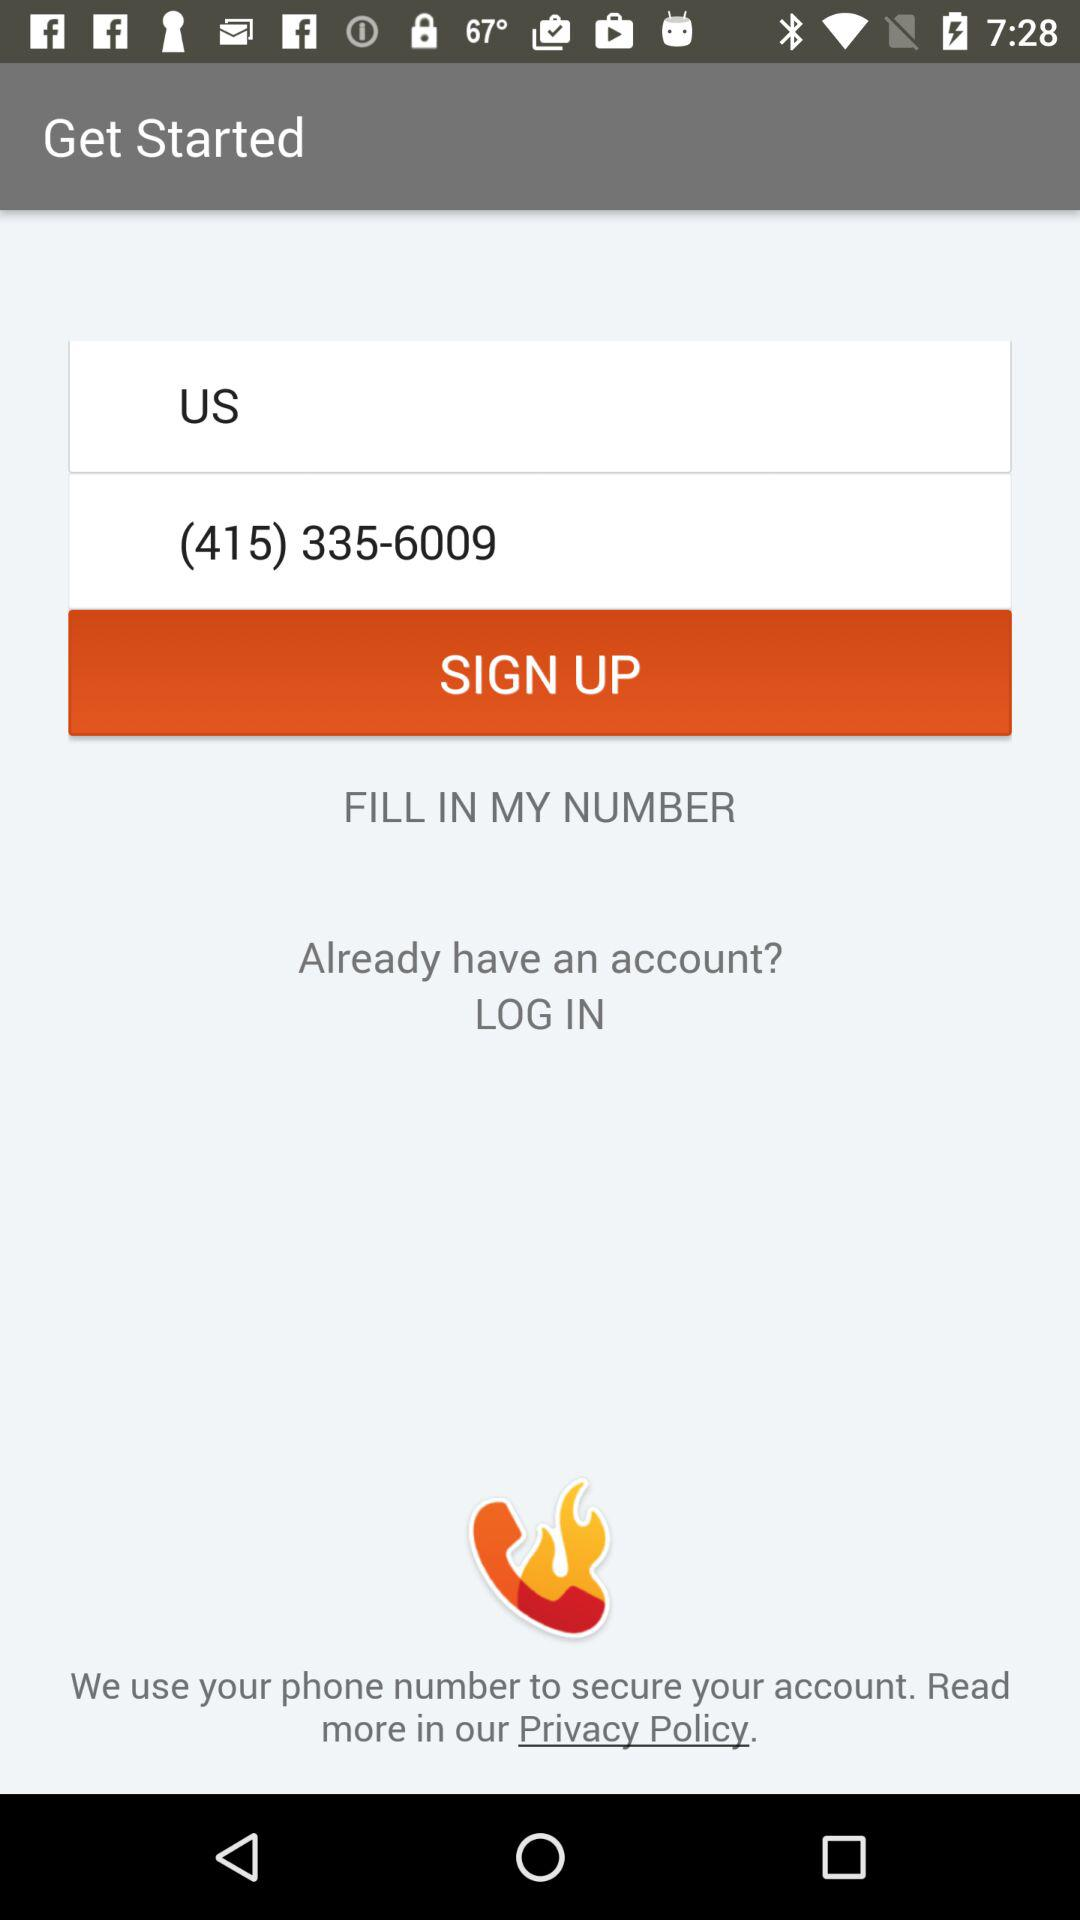Has the user agreed to the privacy policy?
When the provided information is insufficient, respond with <no answer>. <no answer> 